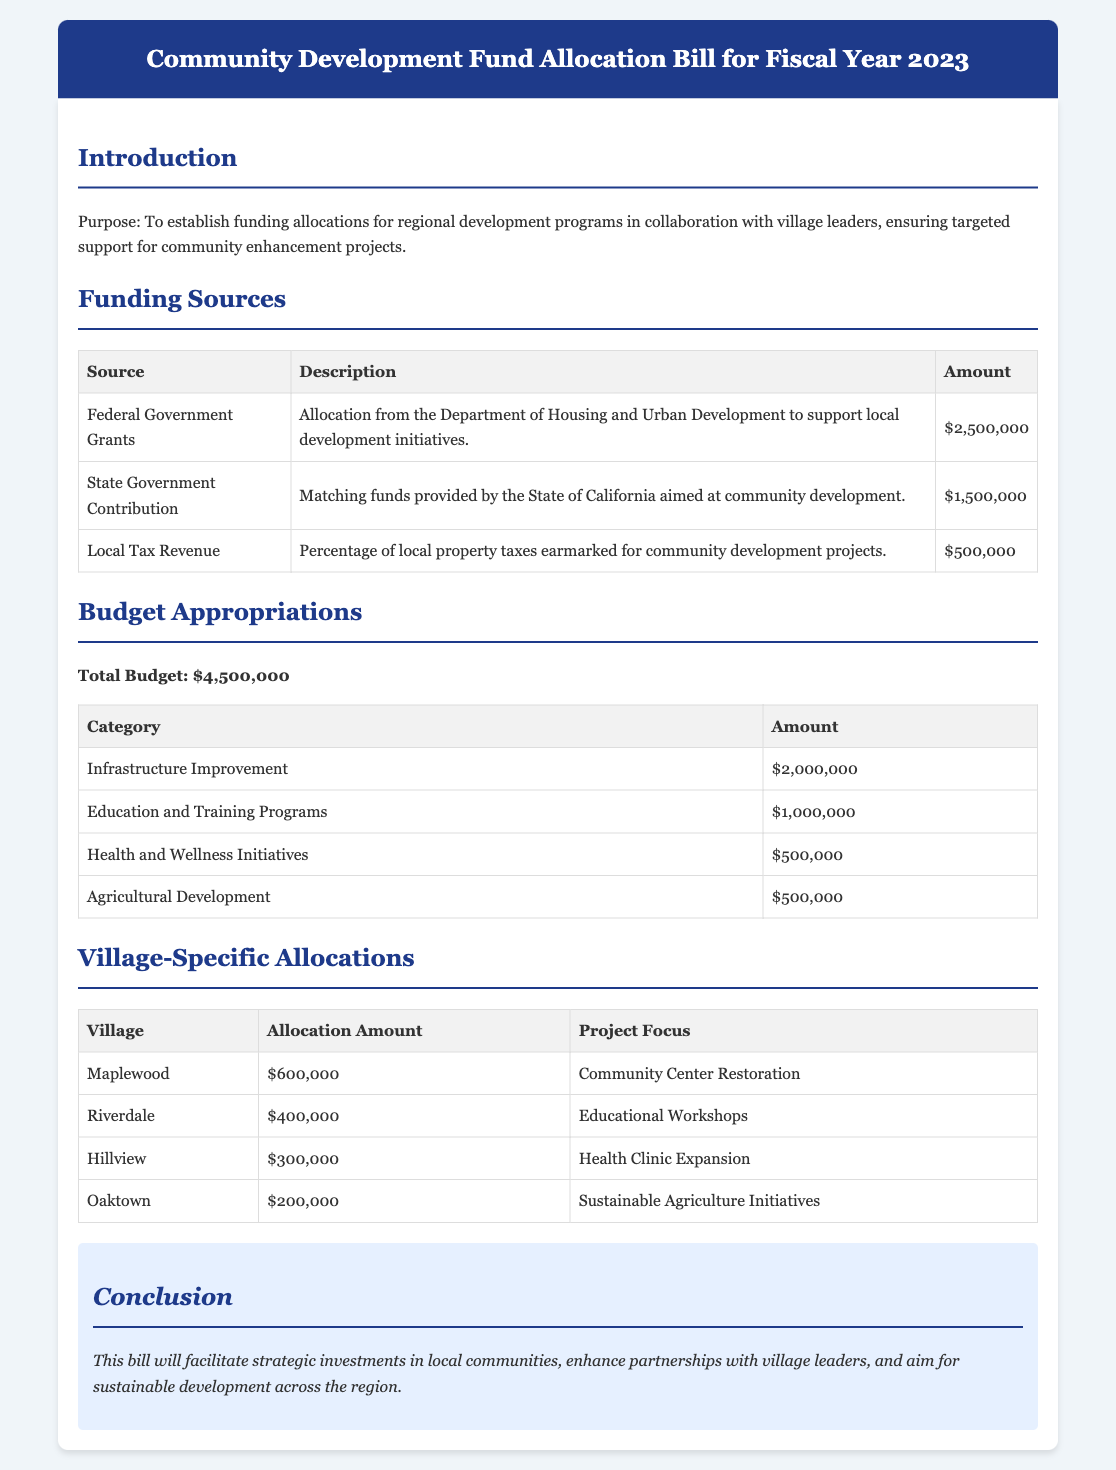What is the total budget for FY 2023? The total budget is specified in the budget appropriations section of the document.
Answer: $4,500,000 How much funding comes from federal grants? The amount from federal grants is detailed in the funding sources section, specifically listed under "Federal Government Grants."
Answer: $2,500,000 What project is funded in Maplewood? The specific project focus for Maplewood is provided in the village-specific allocations table.
Answer: Community Center Restoration Which category has the highest budget allocation? The category with the highest allocation can be determined from the budget appropriations table.
Answer: Infrastructure Improvement What is the total amount allocated to Health and Wellness Initiatives? The allocation amount for Health and Wellness Initiatives is included in the budget appropriations section.
Answer: $500,000 How much is allocated to Riverdale? The allocation amount for Riverdale is found in the village-specific allocations table.
Answer: $400,000 What is the contribution from local tax revenue? The amount from local tax revenue is stated in the funding sources section under "Local Tax Revenue."
Answer: $500,000 What is the main purpose of this bill? The purpose of the bill is outlined in the introduction section.
Answer: To establish funding allocations for regional development programs What type of initiatives does the bill support? The initiatives supported by the bill can be derived from the introduction section that mentions community enhancement projects.
Answer: Community enhancement projects 